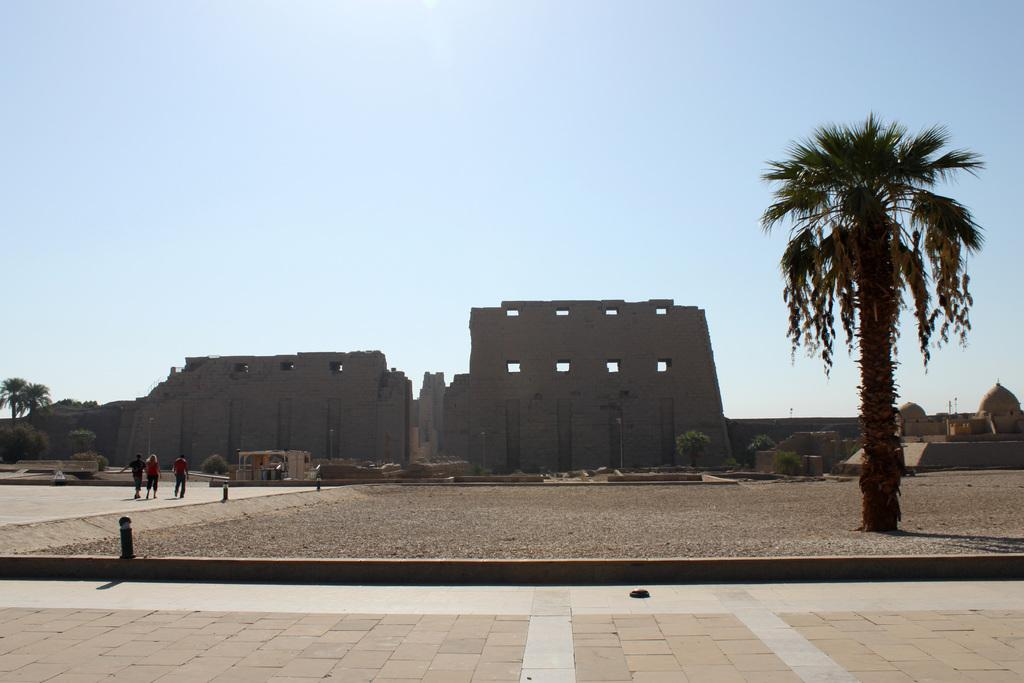Who or what can be seen in the image? There are people in the image. What type of natural elements are present in the image? There are trees and plants in the image. What is the ground like in the image? The ground is visible in the image. Are there any paths or walkways in the image? Yes, there are walkways in the image. What else can be found in the image? There are objects in the image. What can be seen in the background of the image? The background of the image includes forts and walls. What is visible in the sky in the image? The sky is visible in the background of the image. What type of pancake is being served to the friends in the image? There are no friends or pancakes present in the image. 